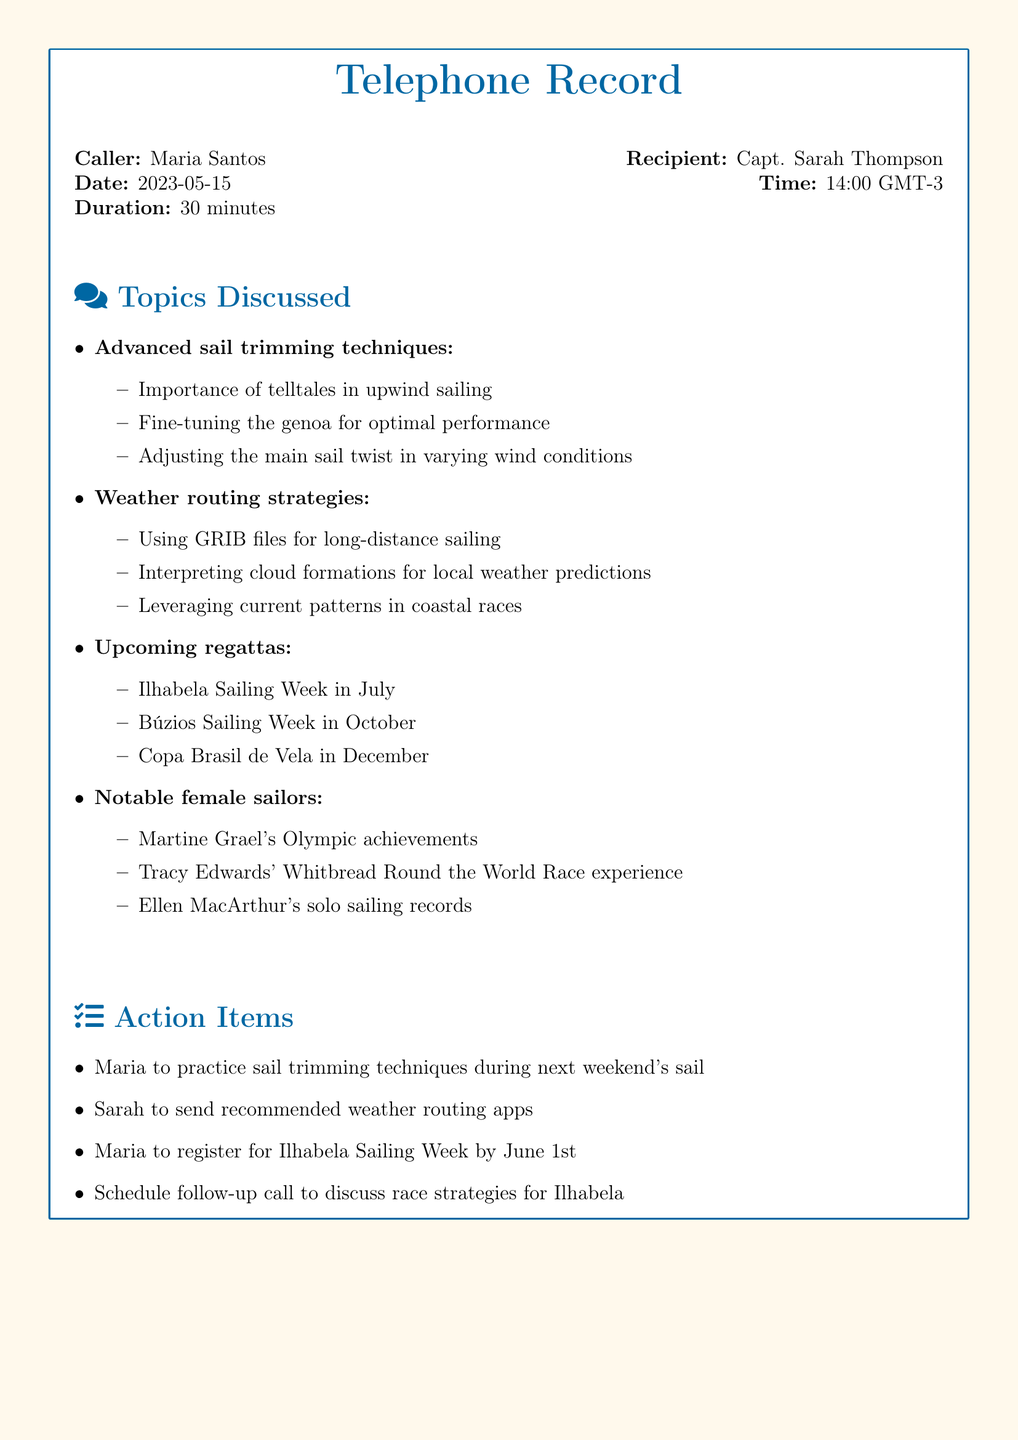What is the name of the caller? The caller's name is mentioned at the beginning of the document.
Answer: Maria Santos Who is the recipient of the call? The recipient's name is listed right after the caller's name.
Answer: Capt. Sarah Thompson What date did the call take place? The call date is specified in the document under the date section.
Answer: 2023-05-15 How long was the call? The duration of the call is provided in the call details.
Answer: 30 minutes Which sailing competition is scheduled for July? The document lists upcoming regattas, noting specific months for each event.
Answer: Ilhabela Sailing Week What are the recommended weather routing apps to be sent by Sarah? The action item indicates Sarah will send apps, although specific names of apps are not mentioned in the document.
Answer: To be determined Name one notable female sailor mentioned. The document lists notable female sailors with context of their achievements.
Answer: Martine Grael What is the action for Maria before the next weekend's sail? The action items detail tasks that Maria needs to perform before the next sail.
Answer: Practice sail trimming techniques By when should Maria register for the Ilhabela Sailing Week? The specific registration deadline for the Ilhabela Sailing Week is noted in the action items.
Answer: June 1st 